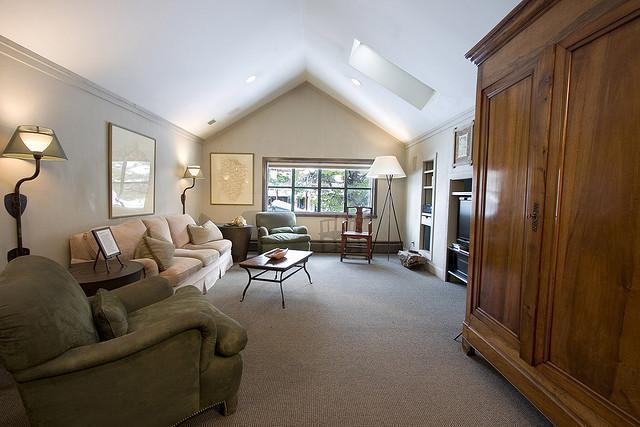How many lamps are in the room?
Give a very brief answer. 3. How many squares are on the window?
Give a very brief answer. 8. How many chairs are in the photo?
Give a very brief answer. 1. 